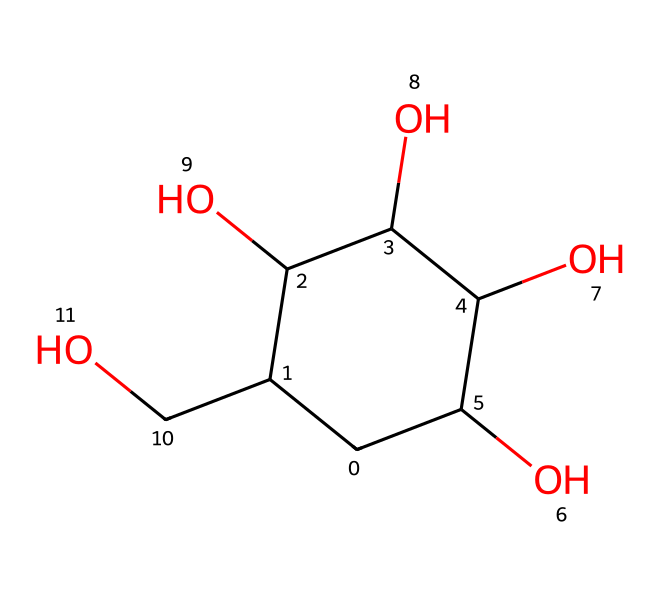what is the molecular formula of the chemical represented by the SMILES? To derive the molecular formula from the SMILES notation, we identify the number of each type of atom in the structure. In this case, we see that there are 6 carbon (C) atoms, 12 hydrogen (H) atoms, and 4 oxygen (O) atoms. Thus, the molecular formula is C6H12O4.
Answer: C6H12O4 how many oxygen atoms are present? From analyzing the SMILES notation, we can count the number of oxygen atoms present in the chemical structure. There are four 'O' letters in the SMILES, indicating there are four oxygen atoms in total.
Answer: 4 how many chiral centers are present in this chemical structure? To identify chiral centers, we look for carbon atoms attached to four different groups or atoms. Examining the structure reveals three carbon atoms that meet this criterion. Thus, there are three chiral centers in the chemical.
Answer: 3 what type of functional group is present in the structure? By inspecting the molecule represented in the SMILES, we can see that there are hydroxyl (-OH) groups present. These functional groups correspond to alcohols, indicating that this is an alcohol compound.
Answer: alcohol what type of carbene representation does this molecule suggest? Carbenes are species with a divalent carbon atom typically bearing a lone pair. In this molecule, there is no divalent carbon present; rather, it is a saturated alcohol compound. Thus, it does not represent a classic carbene structure in terms of reactivity but could have carbene-like characteristics under certain conditions.
Answer: saturated alcohol how many carbon-carbon bonds are present in the structure? To find the number of carbon-carbon (C-C) bonds, we can analyze the structure created by the carbon atoms. By visual examination, we see that there are five connections between adjacent carbon atoms, resulting in a total of five C-C bonds in the structure.
Answer: 5 